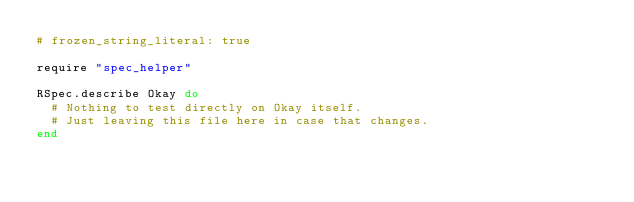Convert code to text. <code><loc_0><loc_0><loc_500><loc_500><_Ruby_># frozen_string_literal: true

require "spec_helper"

RSpec.describe Okay do
  # Nothing to test directly on Okay itself.
  # Just leaving this file here in case that changes.
end
</code> 